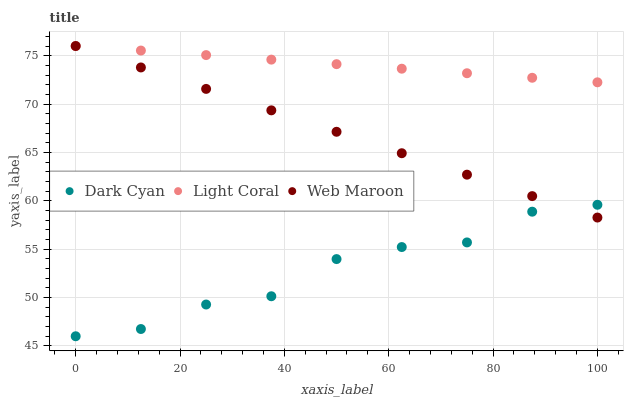Does Dark Cyan have the minimum area under the curve?
Answer yes or no. Yes. Does Light Coral have the maximum area under the curve?
Answer yes or no. Yes. Does Web Maroon have the minimum area under the curve?
Answer yes or no. No. Does Web Maroon have the maximum area under the curve?
Answer yes or no. No. Is Light Coral the smoothest?
Answer yes or no. Yes. Is Dark Cyan the roughest?
Answer yes or no. Yes. Is Web Maroon the smoothest?
Answer yes or no. No. Is Web Maroon the roughest?
Answer yes or no. No. Does Dark Cyan have the lowest value?
Answer yes or no. Yes. Does Web Maroon have the lowest value?
Answer yes or no. No. Does Web Maroon have the highest value?
Answer yes or no. Yes. Is Dark Cyan less than Light Coral?
Answer yes or no. Yes. Is Light Coral greater than Dark Cyan?
Answer yes or no. Yes. Does Web Maroon intersect Light Coral?
Answer yes or no. Yes. Is Web Maroon less than Light Coral?
Answer yes or no. No. Is Web Maroon greater than Light Coral?
Answer yes or no. No. Does Dark Cyan intersect Light Coral?
Answer yes or no. No. 